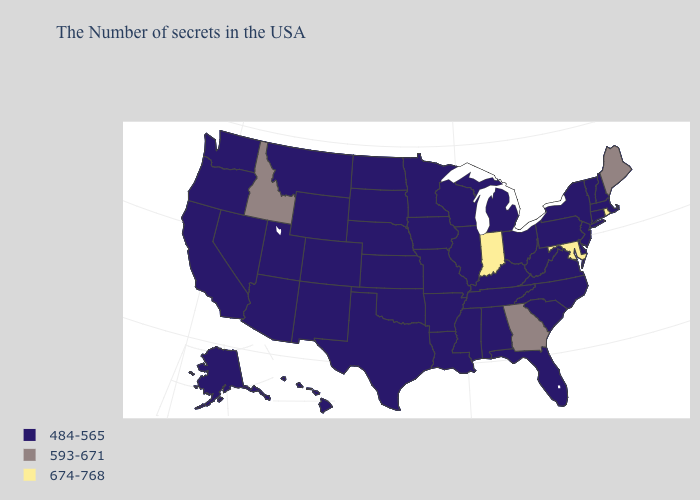Name the states that have a value in the range 484-565?
Concise answer only. Massachusetts, New Hampshire, Vermont, Connecticut, New York, New Jersey, Delaware, Pennsylvania, Virginia, North Carolina, South Carolina, West Virginia, Ohio, Florida, Michigan, Kentucky, Alabama, Tennessee, Wisconsin, Illinois, Mississippi, Louisiana, Missouri, Arkansas, Minnesota, Iowa, Kansas, Nebraska, Oklahoma, Texas, South Dakota, North Dakota, Wyoming, Colorado, New Mexico, Utah, Montana, Arizona, Nevada, California, Washington, Oregon, Alaska, Hawaii. Name the states that have a value in the range 593-671?
Be succinct. Maine, Georgia, Idaho. Does the first symbol in the legend represent the smallest category?
Keep it brief. Yes. Which states have the lowest value in the USA?
Answer briefly. Massachusetts, New Hampshire, Vermont, Connecticut, New York, New Jersey, Delaware, Pennsylvania, Virginia, North Carolina, South Carolina, West Virginia, Ohio, Florida, Michigan, Kentucky, Alabama, Tennessee, Wisconsin, Illinois, Mississippi, Louisiana, Missouri, Arkansas, Minnesota, Iowa, Kansas, Nebraska, Oklahoma, Texas, South Dakota, North Dakota, Wyoming, Colorado, New Mexico, Utah, Montana, Arizona, Nevada, California, Washington, Oregon, Alaska, Hawaii. How many symbols are there in the legend?
Short answer required. 3. Name the states that have a value in the range 674-768?
Short answer required. Rhode Island, Maryland, Indiana. What is the value of Colorado?
Answer briefly. 484-565. What is the value of New York?
Quick response, please. 484-565. Name the states that have a value in the range 593-671?
Short answer required. Maine, Georgia, Idaho. Which states have the lowest value in the USA?
Short answer required. Massachusetts, New Hampshire, Vermont, Connecticut, New York, New Jersey, Delaware, Pennsylvania, Virginia, North Carolina, South Carolina, West Virginia, Ohio, Florida, Michigan, Kentucky, Alabama, Tennessee, Wisconsin, Illinois, Mississippi, Louisiana, Missouri, Arkansas, Minnesota, Iowa, Kansas, Nebraska, Oklahoma, Texas, South Dakota, North Dakota, Wyoming, Colorado, New Mexico, Utah, Montana, Arizona, Nevada, California, Washington, Oregon, Alaska, Hawaii. Name the states that have a value in the range 674-768?
Give a very brief answer. Rhode Island, Maryland, Indiana. Name the states that have a value in the range 593-671?
Keep it brief. Maine, Georgia, Idaho. What is the value of Kentucky?
Concise answer only. 484-565. Name the states that have a value in the range 593-671?
Answer briefly. Maine, Georgia, Idaho. 